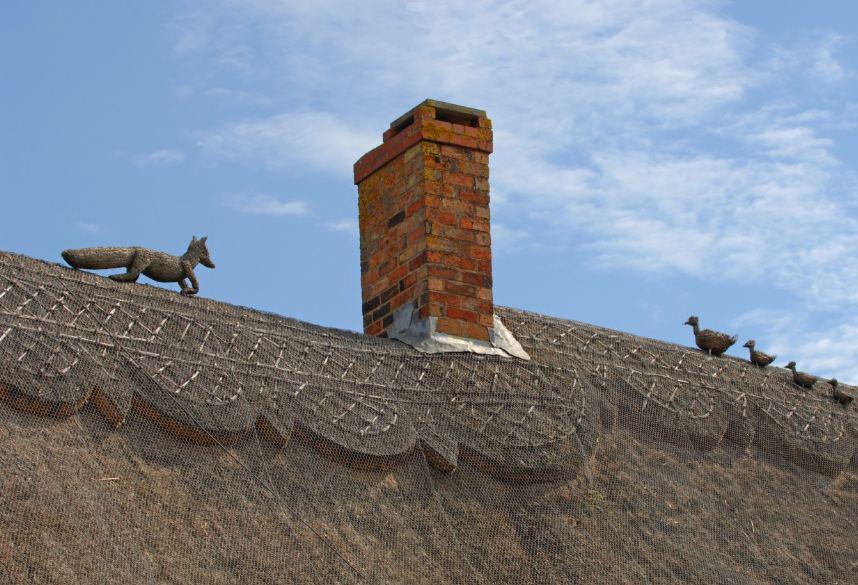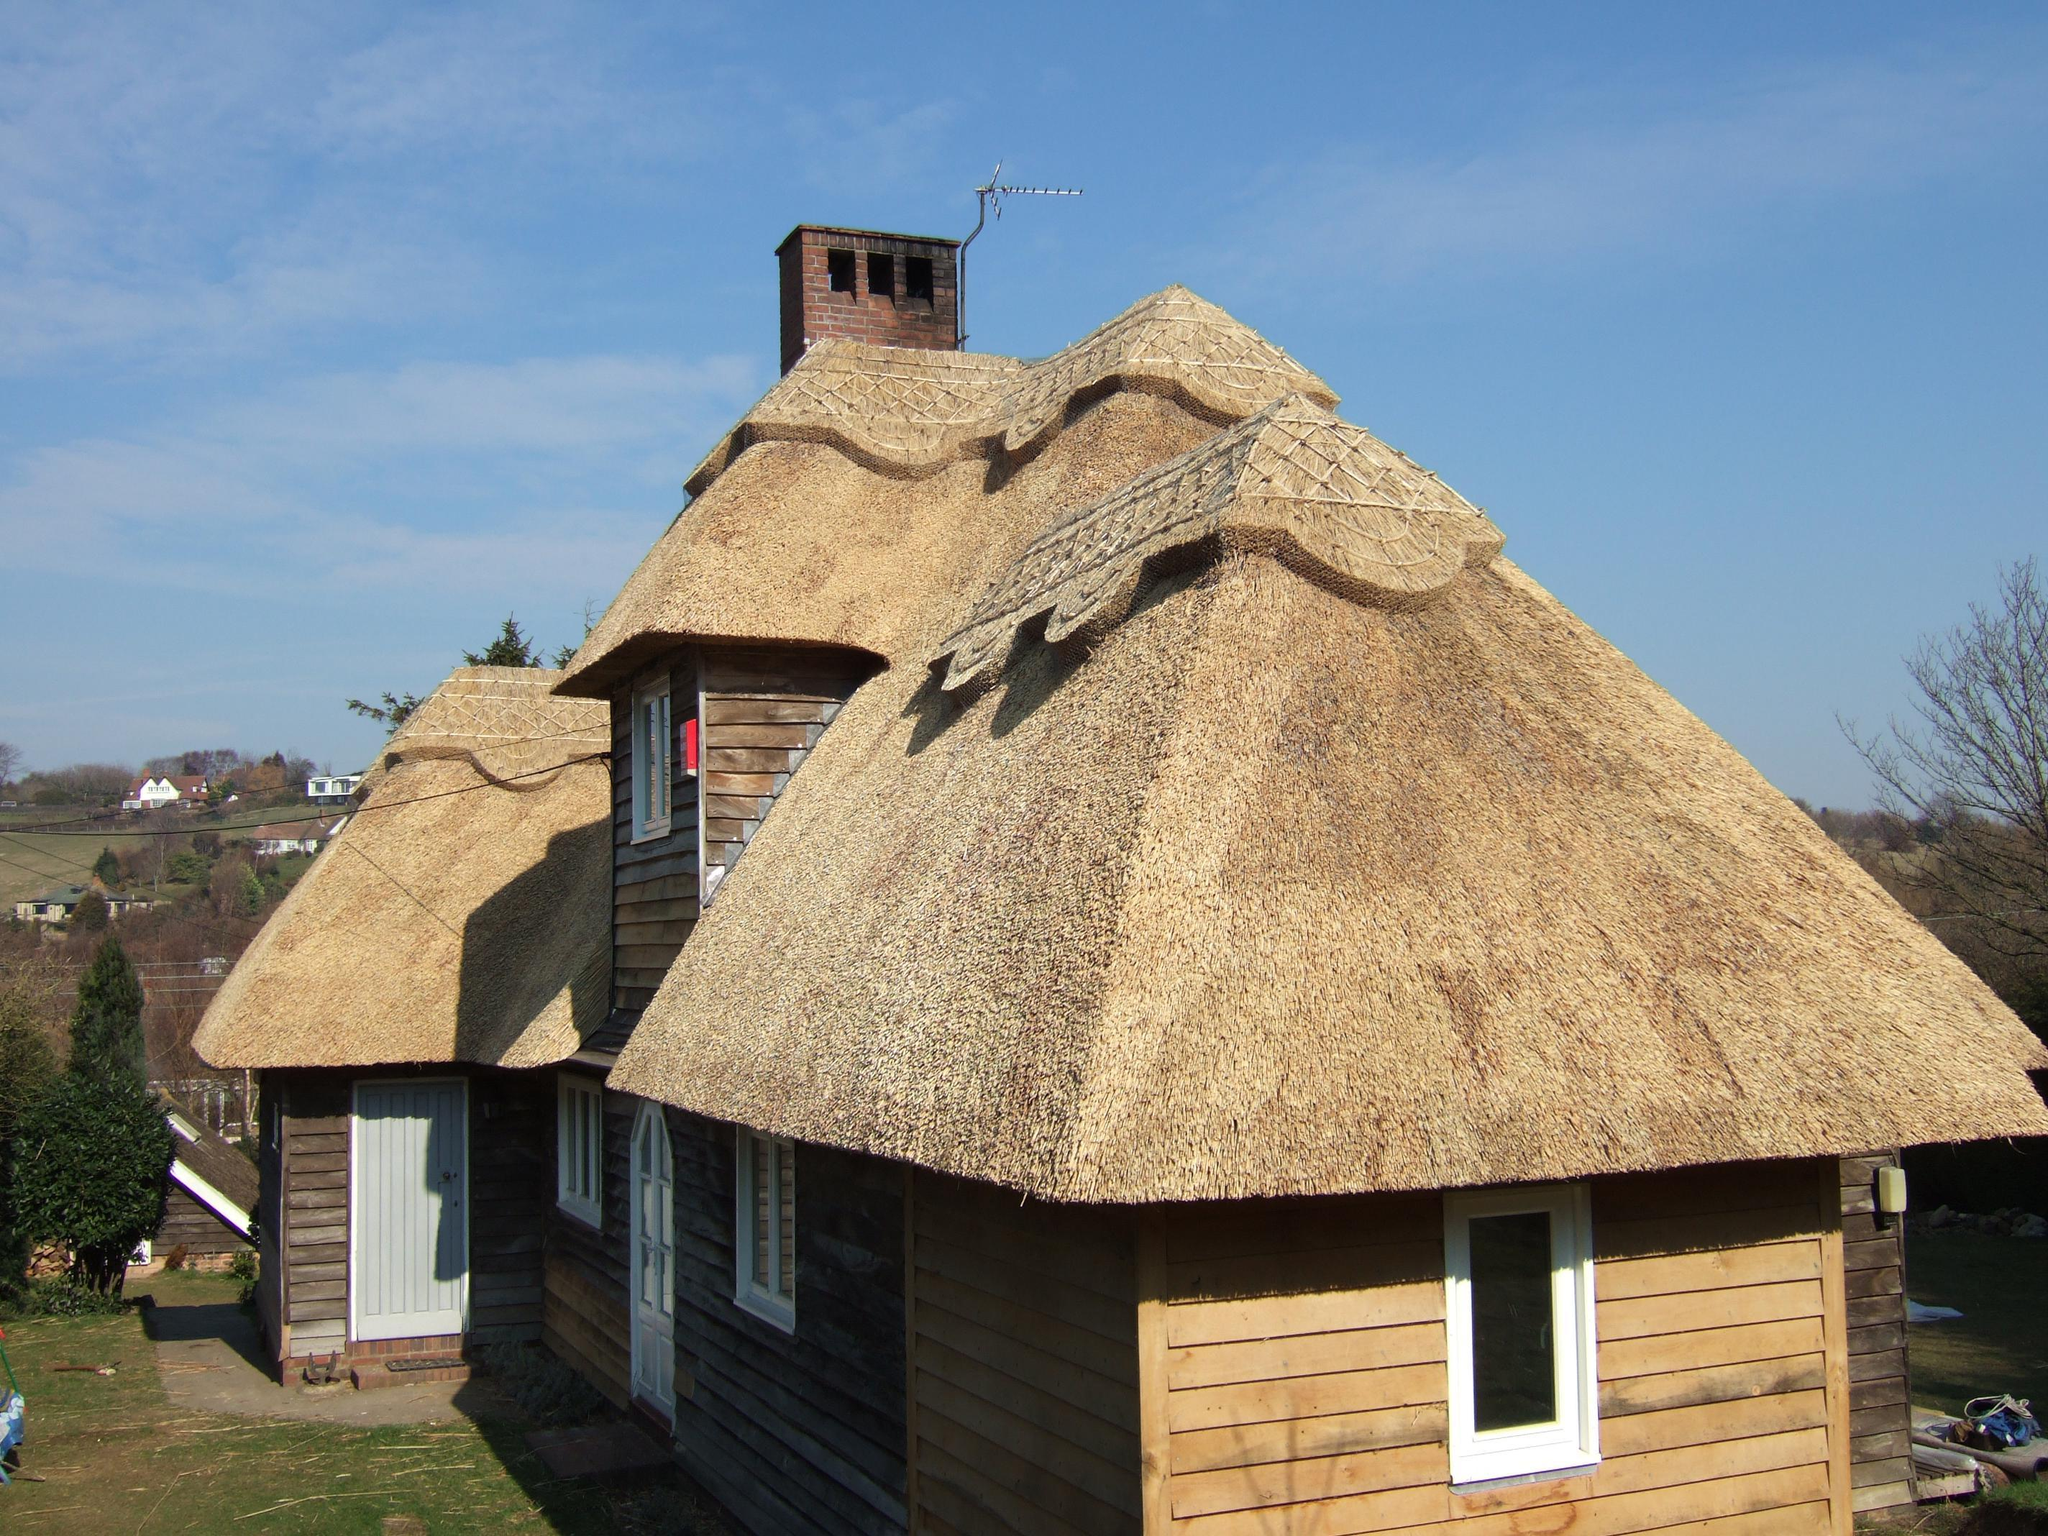The first image is the image on the left, the second image is the image on the right. Evaluate the accuracy of this statement regarding the images: "In at least one image there is a house with at least 3 white framed windows and the house and chimney are put together by brick.". Is it true? Answer yes or no. Yes. The first image is the image on the left, the second image is the image on the right. Examine the images to the left and right. Is the description "Each image shows a building with at least one chimney extending up out of a roof with a sculptural decorative cap over its peaked edge." accurate? Answer yes or no. Yes. 